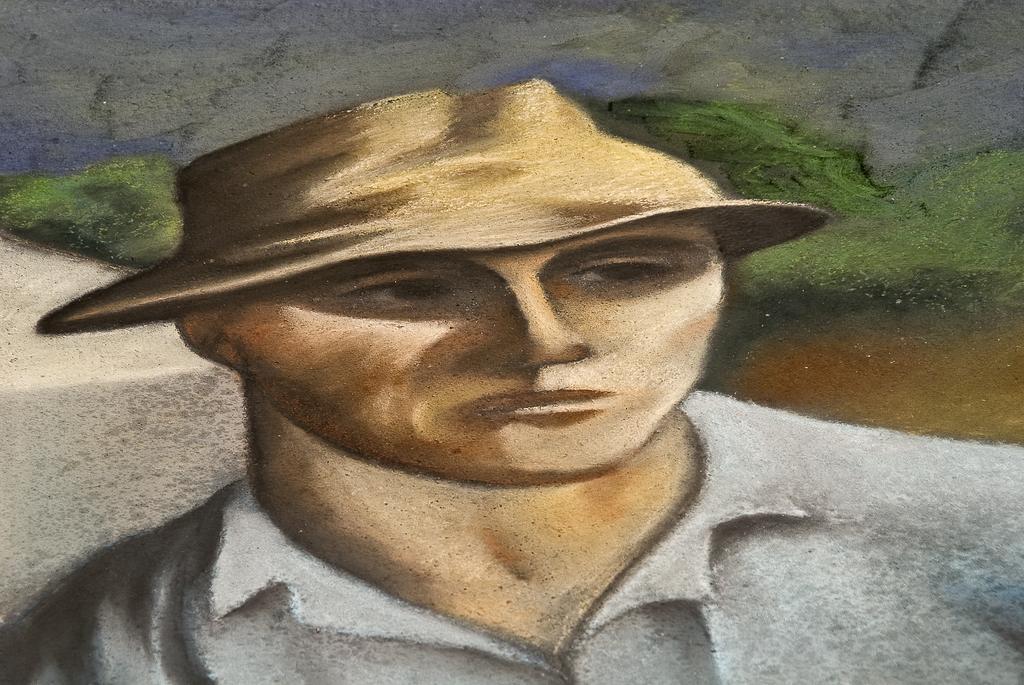Please provide a concise description of this image. In this image we can see a painting of a person. At the back side there are trees and water. 